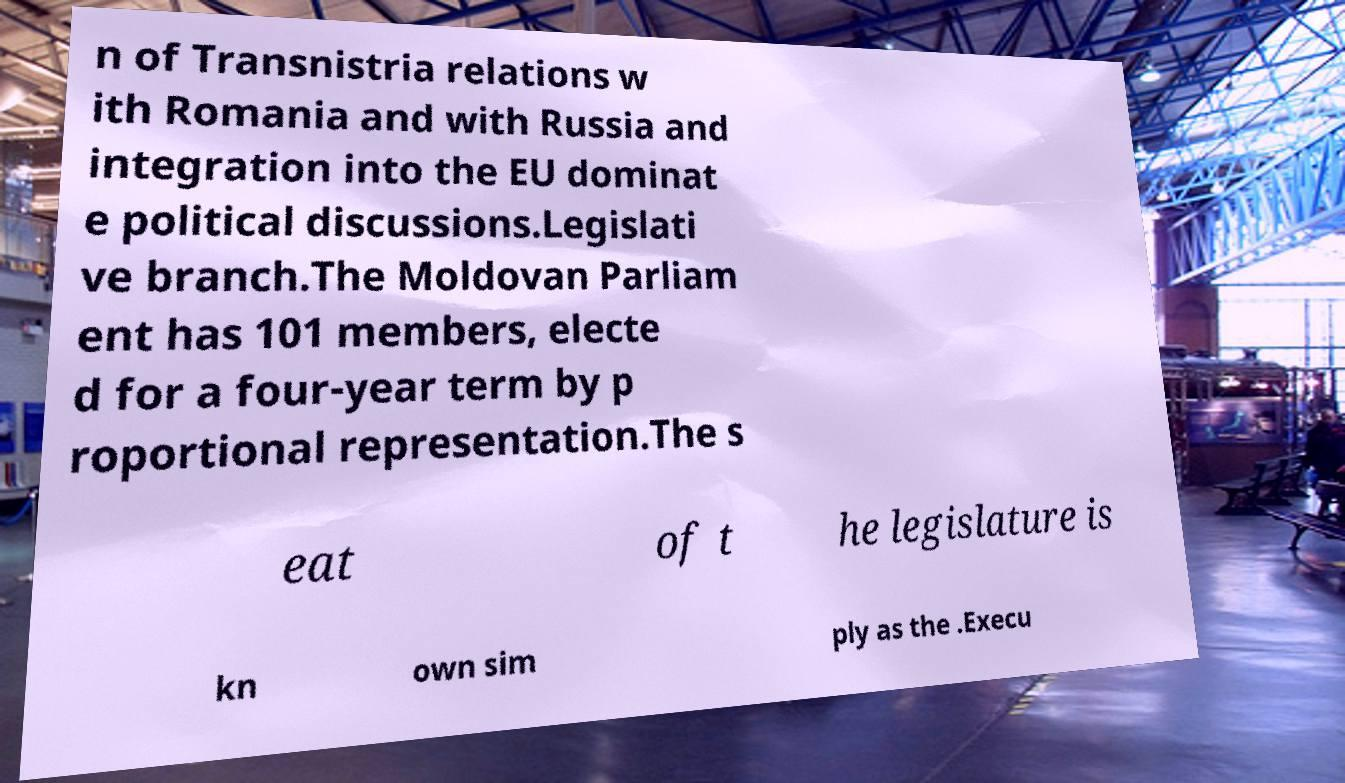Can you accurately transcribe the text from the provided image for me? n of Transnistria relations w ith Romania and with Russia and integration into the EU dominat e political discussions.Legislati ve branch.The Moldovan Parliam ent has 101 members, electe d for a four-year term by p roportional representation.The s eat of t he legislature is kn own sim ply as the .Execu 